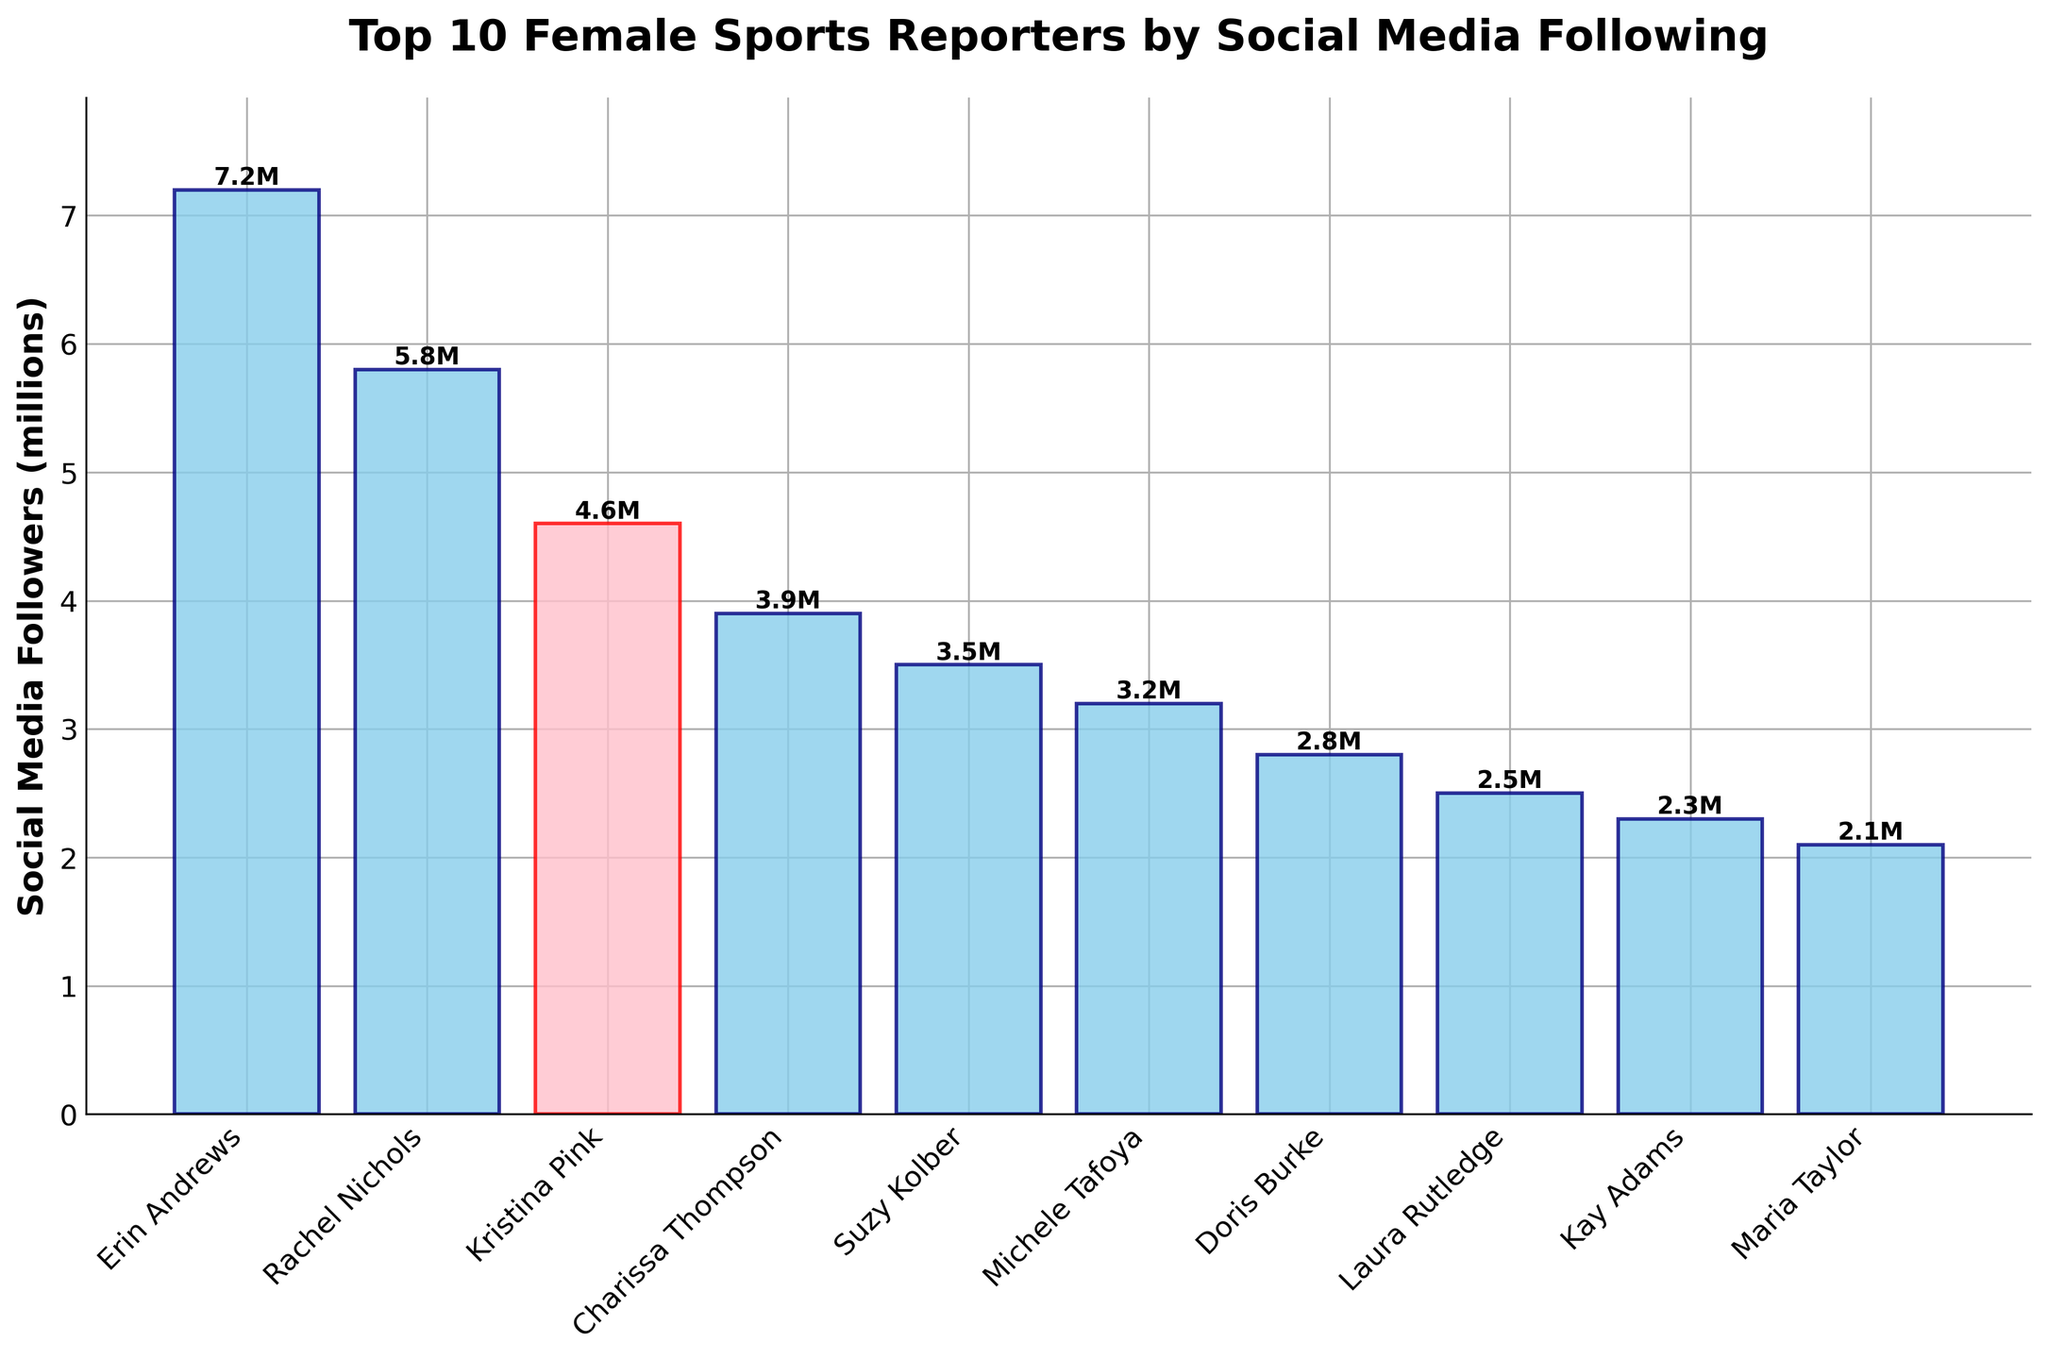Which sports reporter has the highest number of social media followers? The bar for Erin Andrews reaches the highest point at 7.2 million followers, which is above all other bars.
Answer: Erin Andrews Which two reporters have the closest number of followers? Michele Tafoya has 3.2 million and Doris Burke has 2.8 million followers, they are only 0.4 million apart compared to others.
Answer: Michele Tafoya and Doris Burke What is the total number of social media followers for the reporters ranked 1st, 5th, and 10th? Erin Andrews has 7.2 million, Suzy Kolber has 3.5 million, and Maria Taylor has 2.1 million followers. Summing them up: 7.2 + 3.5 + 2.1 = 12.8 million.
Answer: 12.8 million How much more does Rachel Nichols have compared to Maria Taylor? Rachel Nichols has 5.8 million followers and Maria Taylor has 2.1 million. Subtracting them: 5.8 - 2.1 = 3.7 million.
Answer: 3.7 million Which reporter stands out visually in the graph and why? Kristina Pink is highlighted with pink color and a red edge, distinguishing her from the others.
Answer: Kristina Pink What is the difference in social media followers between the second and third most-followed reporters? Rachel Nichols has 5.8 million followers, and Kristina Pink has 4.6 million. The difference is 5.8 - 4.6 = 1.2 million.
Answer: 1.2 million How many reporters have more than 4 million followers? Erin Andrews, Rachel Nichols, and Kristina Pink each have more than 4 million followers. Counting them gives 3.
Answer: 3 Which reporter has the least social media followers and how many? Maria Taylor has the shortest bar, indicating she has the least number of social media followers, which is 2.1 million.
Answer: Maria Taylor, 2.1 million What proportion of the followers does Kristina Pink have compared to Erin Andrews? Kristina Pink has 4.6 million followers and Erin Andrews has 7.2 million. The proportion is 4.6 / 7.2 ≈ 0.639, or about 63.9%.
Answer: About 63.9% Who has more followers, Charissa Thompson or Suzy Kolber, and by how much? Charissa Thompson has 3.9 million followers and Suzy Kolber has 3.5 million. The difference is 3.9 - 3.5 = 0.4 million.
Answer: Charissa Thompson, 0.4 million 